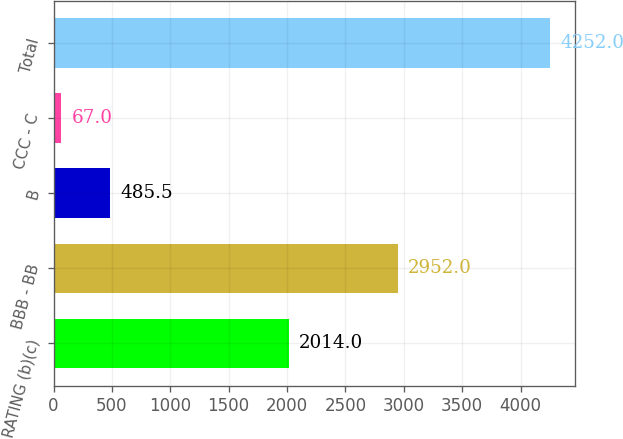Convert chart. <chart><loc_0><loc_0><loc_500><loc_500><bar_chart><fcel>RATING (b)(c)<fcel>BBB - BB<fcel>B<fcel>CCC - C<fcel>Total<nl><fcel>2014<fcel>2952<fcel>485.5<fcel>67<fcel>4252<nl></chart> 